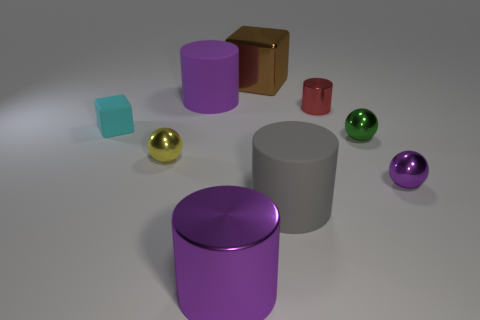What is the size of the shiny ball that is the same color as the large metallic cylinder?
Your response must be concise. Small. There is a brown cube; does it have the same size as the metallic sphere to the left of the brown metallic cube?
Ensure brevity in your answer.  No. What number of cylinders are either small cyan things or brown shiny things?
Provide a succinct answer. 0. What size is the yellow object that is the same material as the purple ball?
Ensure brevity in your answer.  Small. There is a sphere that is on the left side of the tiny shiny cylinder; is it the same size as the shiny cylinder that is behind the big shiny cylinder?
Make the answer very short. Yes. How many objects are either large blue blocks or tiny matte blocks?
Your answer should be compact. 1. The small purple thing has what shape?
Your answer should be very brief. Sphere. What is the size of the purple object that is the same shape as the yellow metal thing?
Your response must be concise. Small. Is there anything else that is made of the same material as the brown thing?
Offer a terse response. Yes. What is the size of the rubber cylinder right of the big metallic thing in front of the brown metal block?
Make the answer very short. Large. 